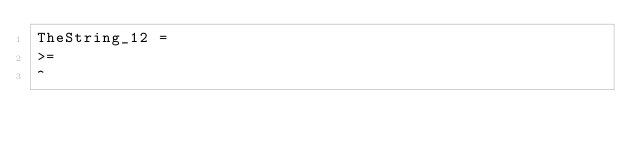Convert code to text. <code><loc_0><loc_0><loc_500><loc_500><_SQL_>TheString_12 = 
>=
^</code> 